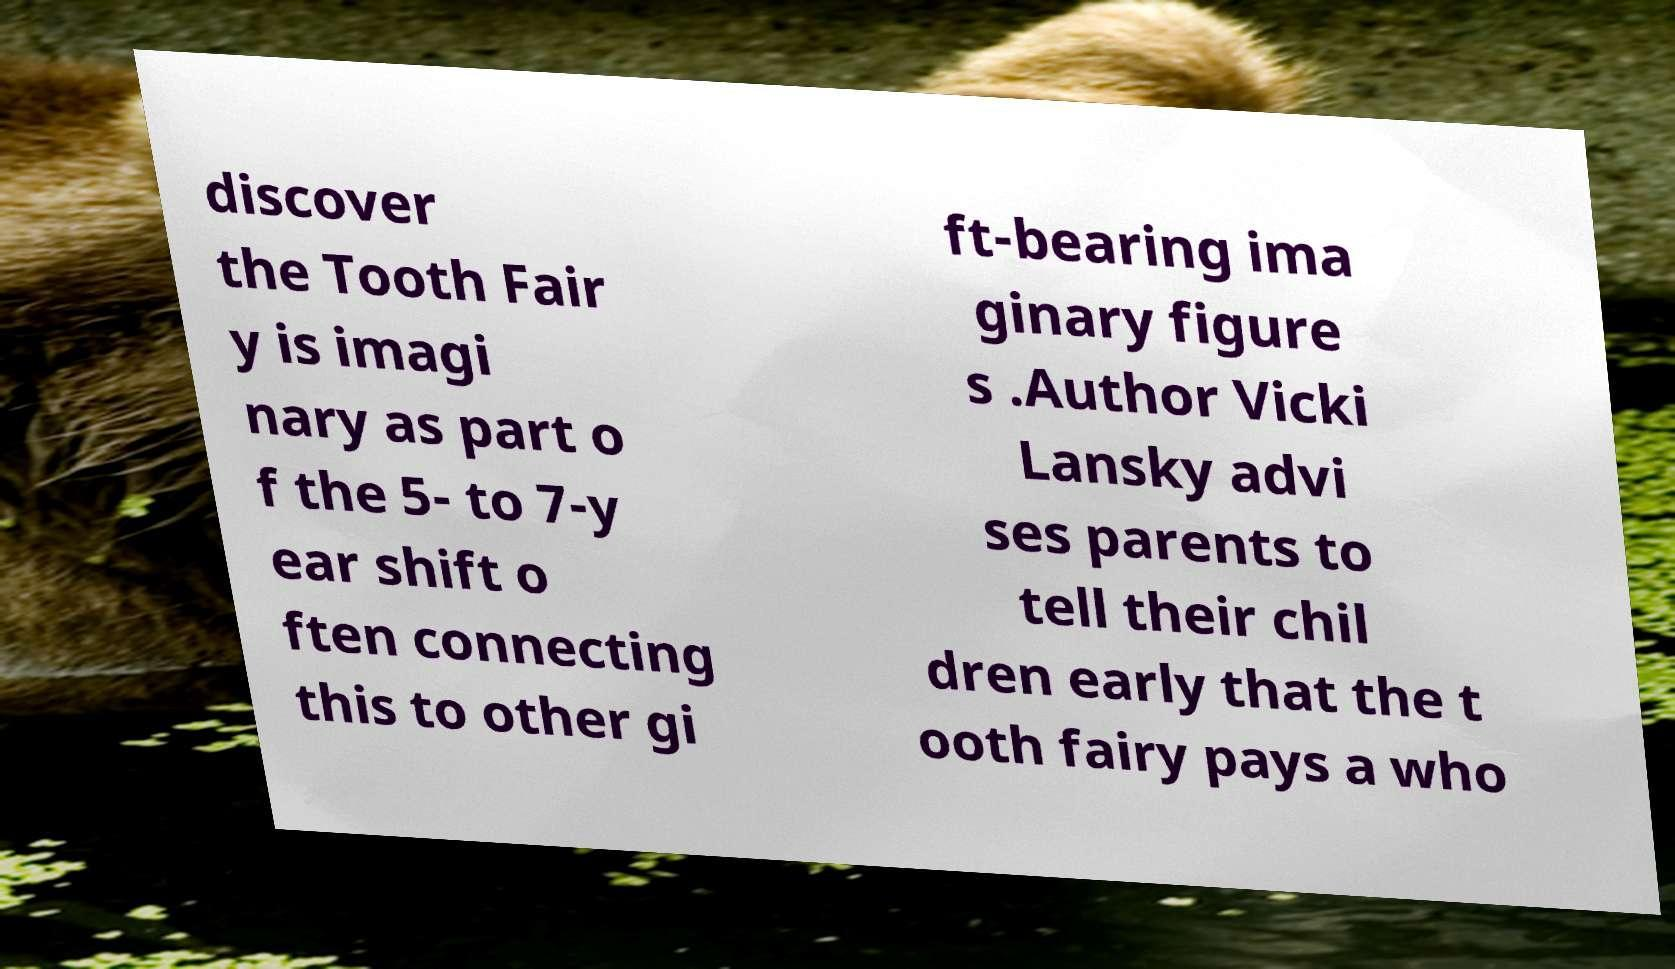Could you assist in decoding the text presented in this image and type it out clearly? discover the Tooth Fair y is imagi nary as part o f the 5- to 7-y ear shift o ften connecting this to other gi ft-bearing ima ginary figure s .Author Vicki Lansky advi ses parents to tell their chil dren early that the t ooth fairy pays a who 